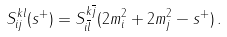Convert formula to latex. <formula><loc_0><loc_0><loc_500><loc_500>S _ { i j } ^ { k l } ( s ^ { + } ) = S _ { i \overline { l } } ^ { k \overline { j } } ( 2 m _ { i } ^ { 2 } + 2 m _ { j } ^ { 2 } - s ^ { + } ) \, .</formula> 